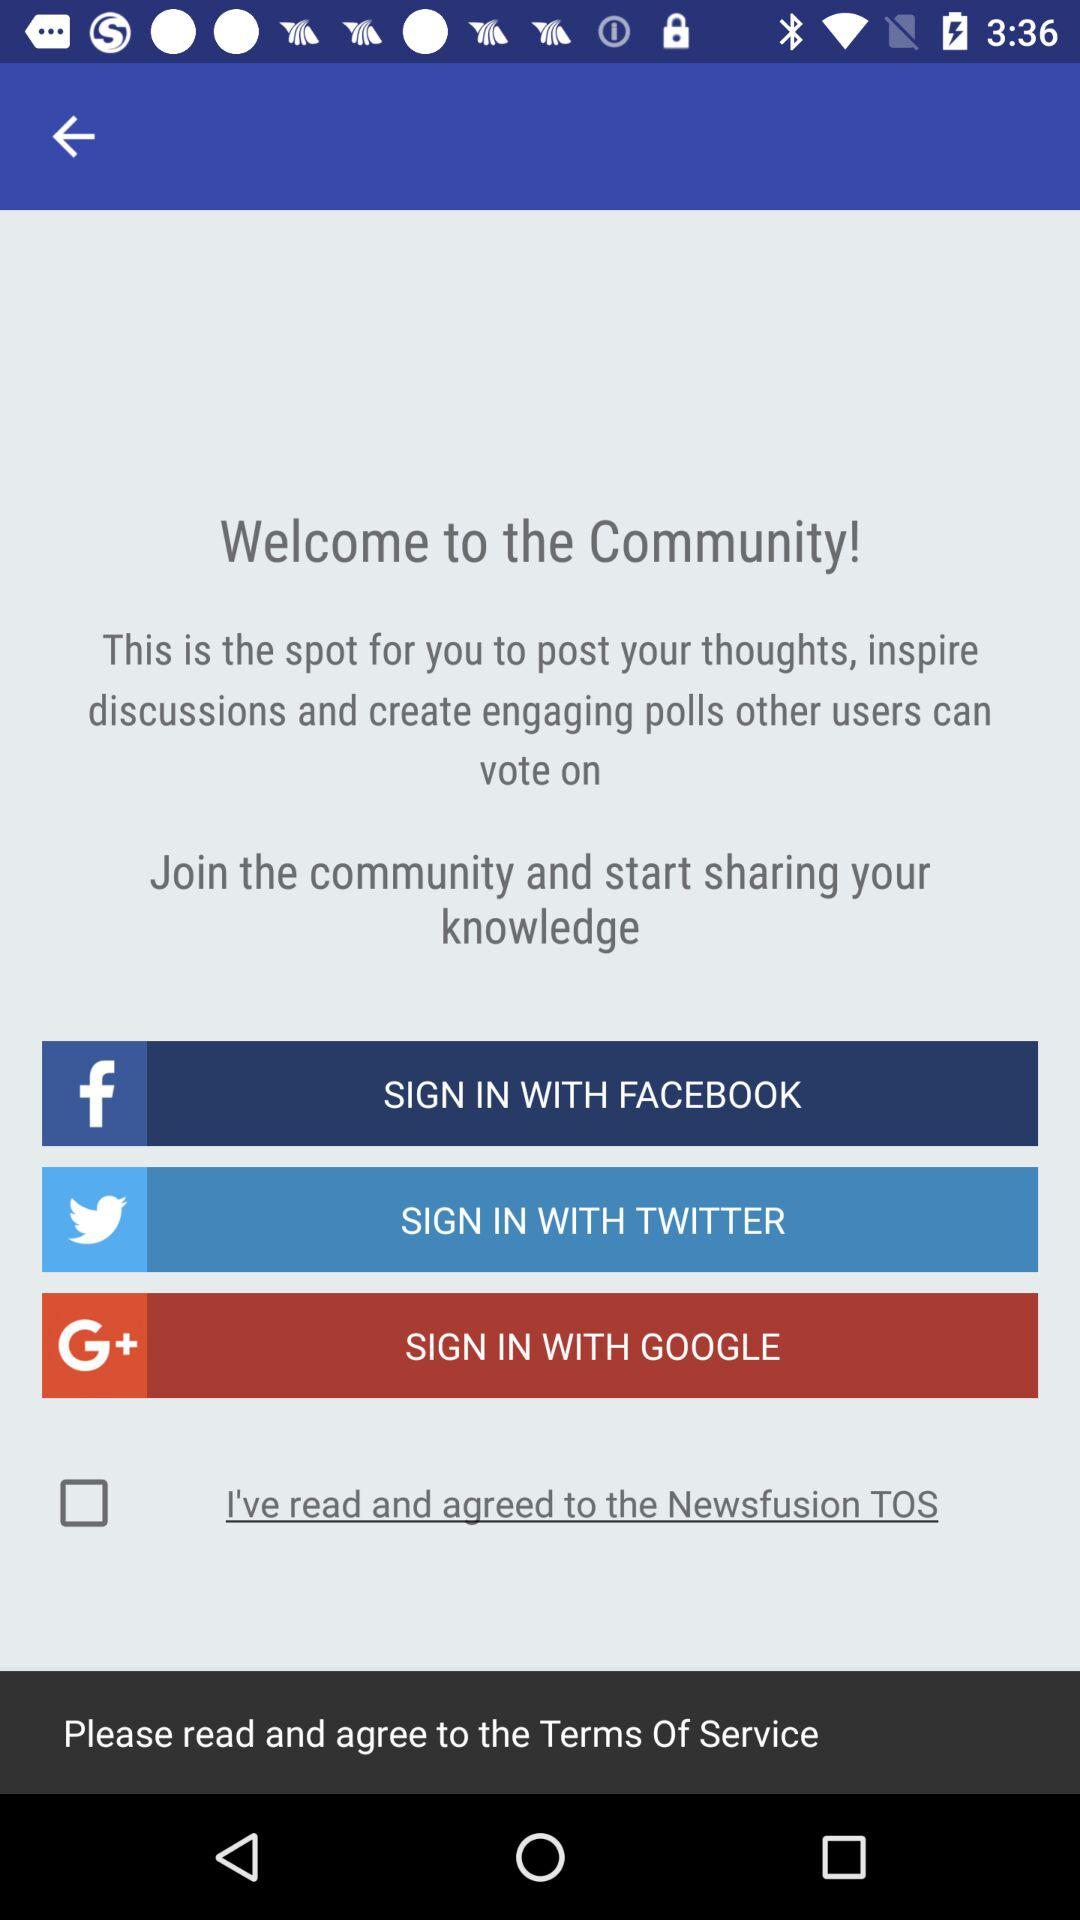What is the status of "I've read and agreed to the Newsfusion TOS"? The status is "off". 